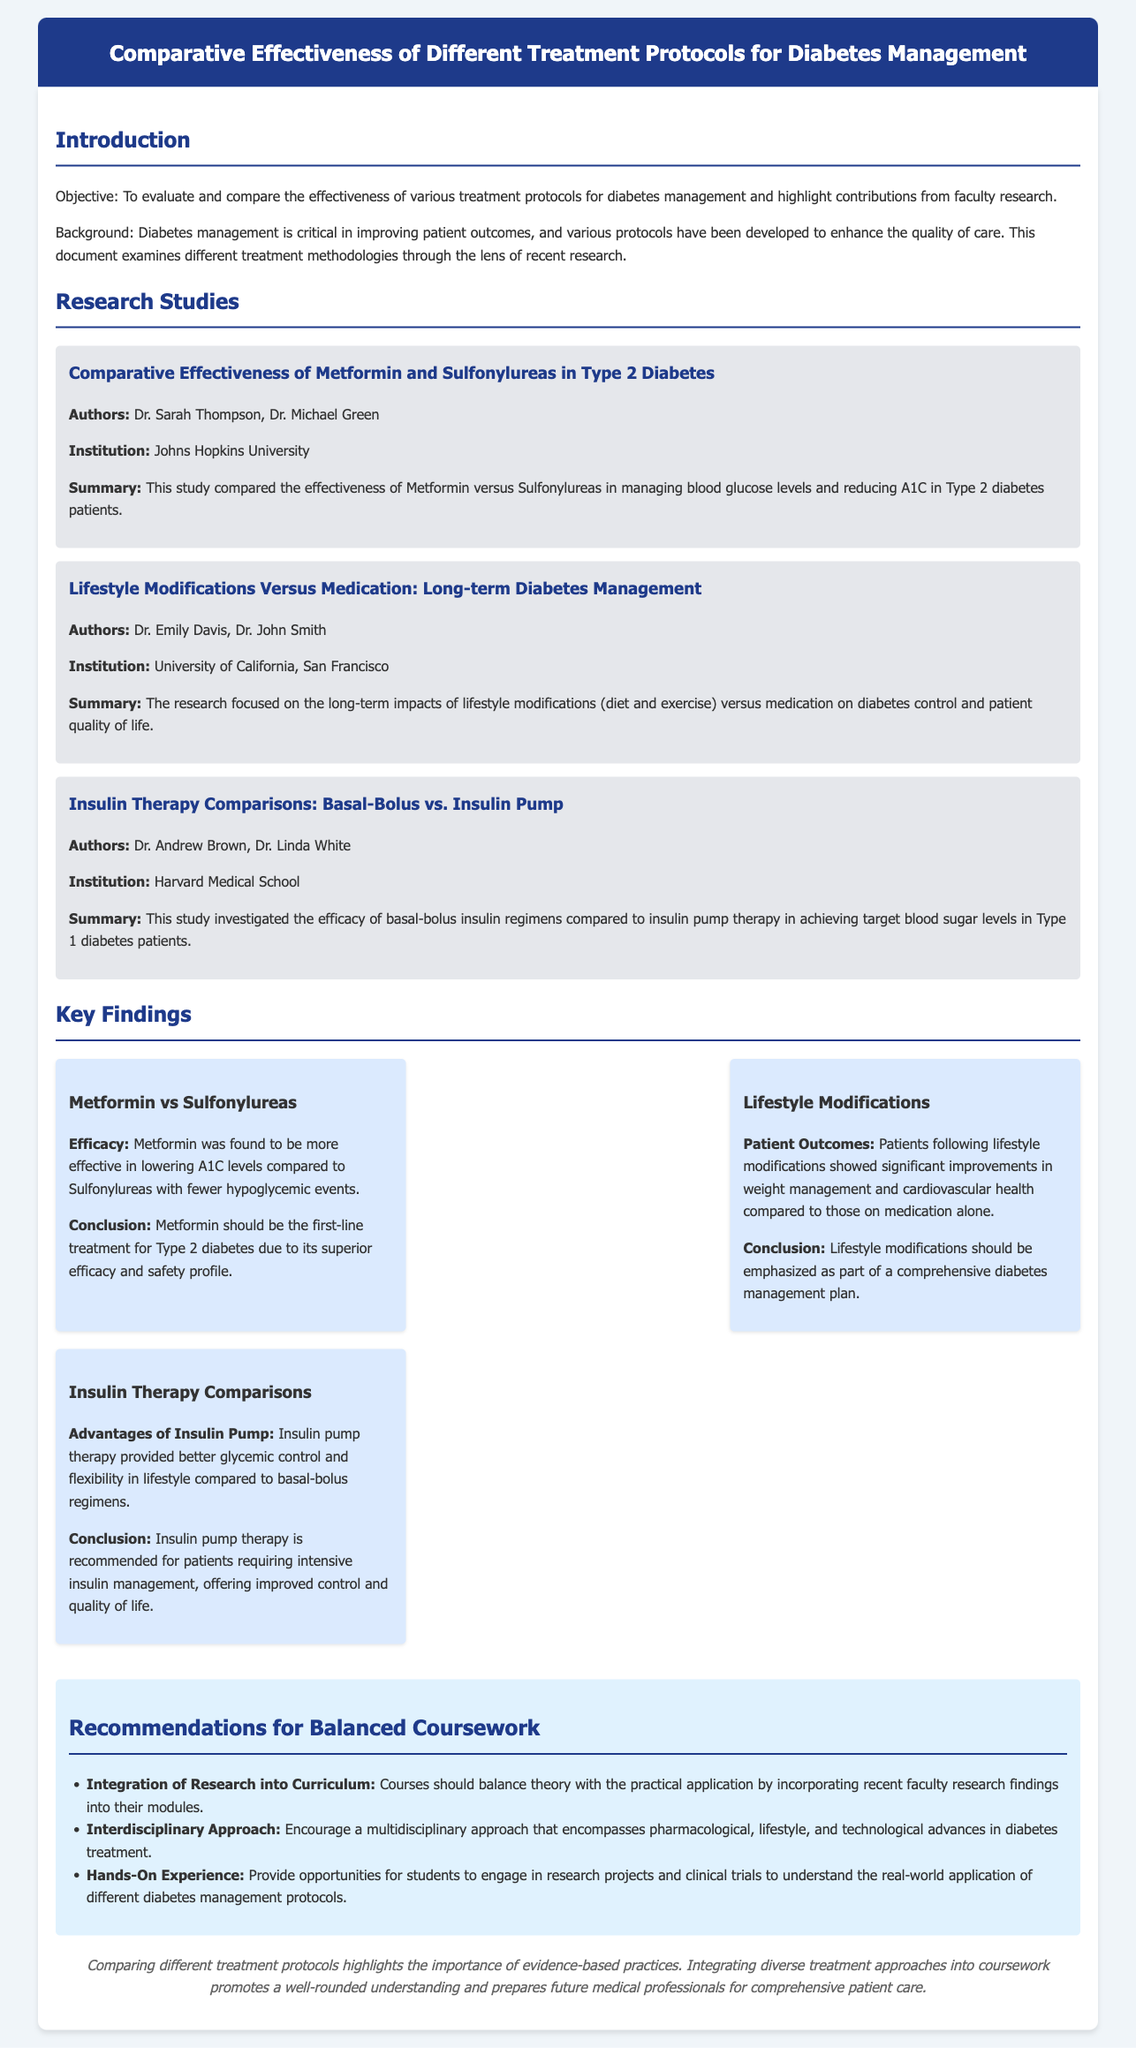What is the objective of the document? The objective is to evaluate and compare the effectiveness of various treatment protocols for diabetes management and highlight contributions from faculty research.
Answer: To evaluate and compare the effectiveness of various treatment protocols for diabetes management Who are the authors of the study on Metformin and Sulfonylureas? The authors listed for this study are Dr. Sarah Thompson and Dr. Michael Green.
Answer: Dr. Sarah Thompson, Dr. Michael Green What was the conclusion of the lifestyle modifications study? The conclusion states that lifestyle modifications should be emphasized as part of a comprehensive diabetes management plan.
Answer: Lifestyle modifications should be emphasized Which institution conducted the research on insulin therapy comparisons? Harvard Medical School is the institution mentioned for the insulin therapy comparisons study.
Answer: Harvard Medical School What is one key finding regarding the use of Metformin? The key finding is that Metformin was found to be more effective in lowering A1C levels compared to Sulfonylureas with fewer hypoglycemic events.
Answer: More effective in lowering A1C levels What recommendation was made regarding the course curriculum? The recommendation was to integrate recent faculty research findings into the curriculum.
Answer: Integrate research into curriculum How many studies are summarized in the document? There are three studies summarized in the document.
Answer: Three studies What is the title of the second research study mentioned? The title of the second research study is "Lifestyle Modifications Versus Medication: Long-term Diabetes Management."
Answer: Lifestyle Modifications Versus Medication: Long-term Diabetes Management What is emphasized as part of a comprehensive diabetes management plan? Lifestyle modifications are emphasized as part of a comprehensive diabetes management plan.
Answer: Lifestyle modifications 